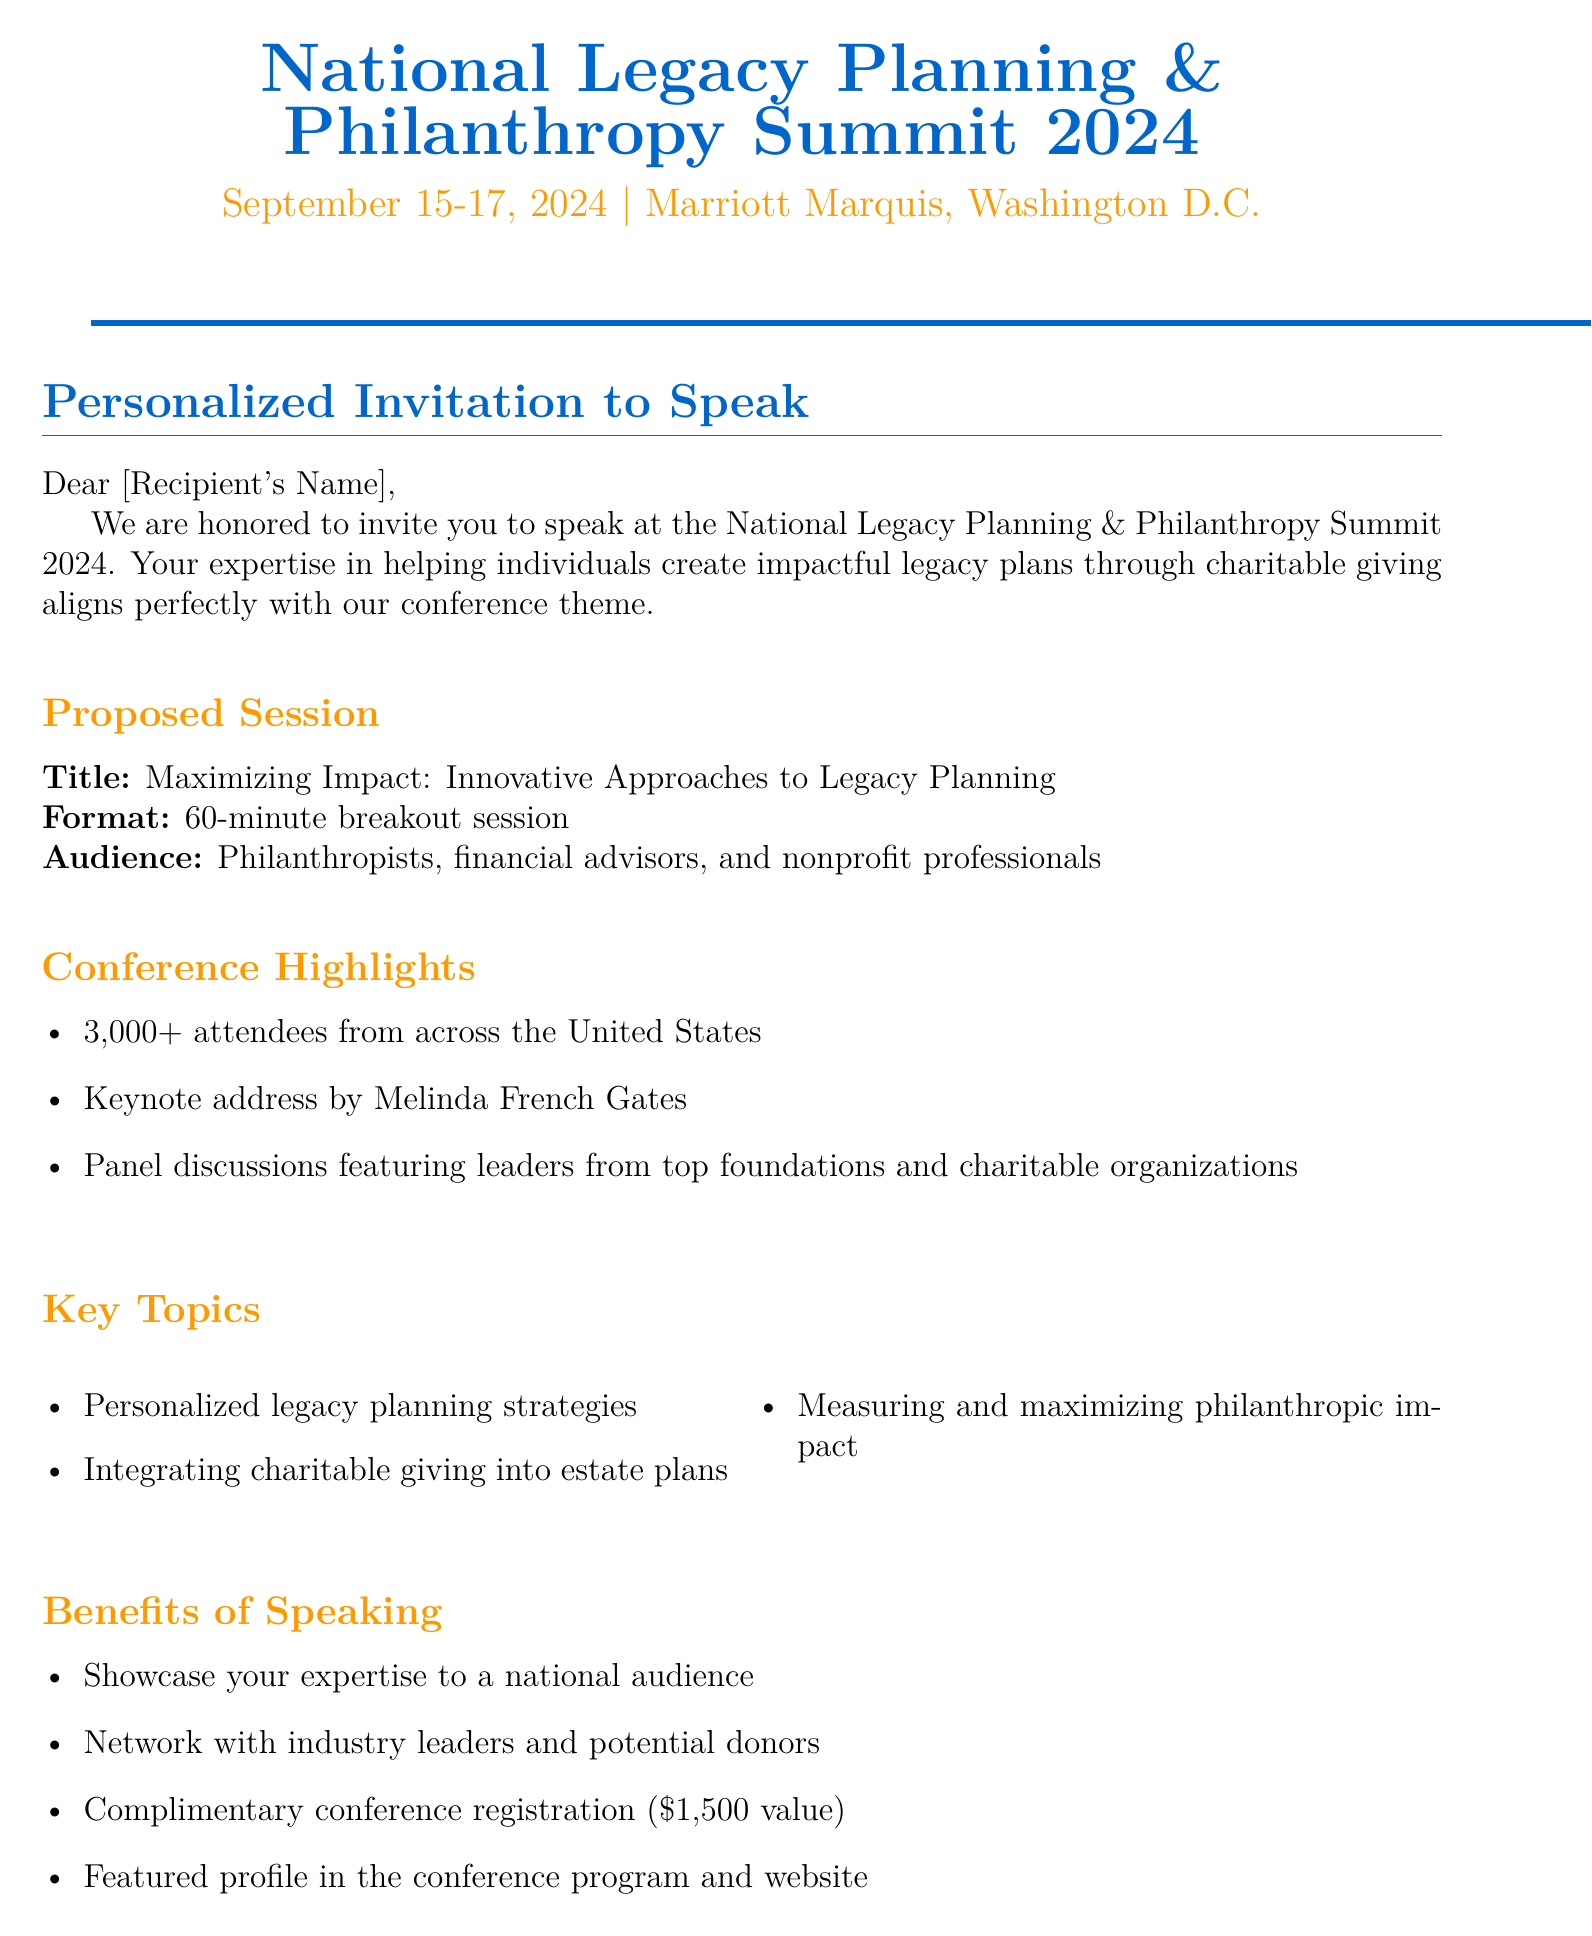what is the name of the conference? The name of the conference is mentioned in the invitation header as "National Legacy Planning & Philanthropy Summit 2024."
Answer: National Legacy Planning & Philanthropy Summit 2024 when is the conference scheduled? The date of the conference is specified in the invitation header.
Answer: September 15-17, 2024 where will the conference take place? The location of the conference is stated in the invitation header.
Answer: Marriott Marquis, Washington D.C who is the keynote speaker? The document highlights that the keynote address will be given by Melinda French Gates.
Answer: Melinda French Gates what is the proposed session title? The proposed session title is specified under speaker details in the document.
Answer: Maximizing Impact: Innovative Approaches to Legacy Planning who is the conference chair? The name of the conference chair is listed at the end of the document.
Answer: Emily Rodriguez what is the value of the complimentary conference registration? The value of the complimentary registration is mentioned when discussing the benefits of speaking.
Answer: $1,500 what materials are required for submission? The document outlines the required materials under submission instructions.
Answer: Brief session outline, Speaker bio, High-resolution headshot when is the submission deadline? The submission deadline is clearly stated in the submission instructions.
Answer: April 30, 2024 